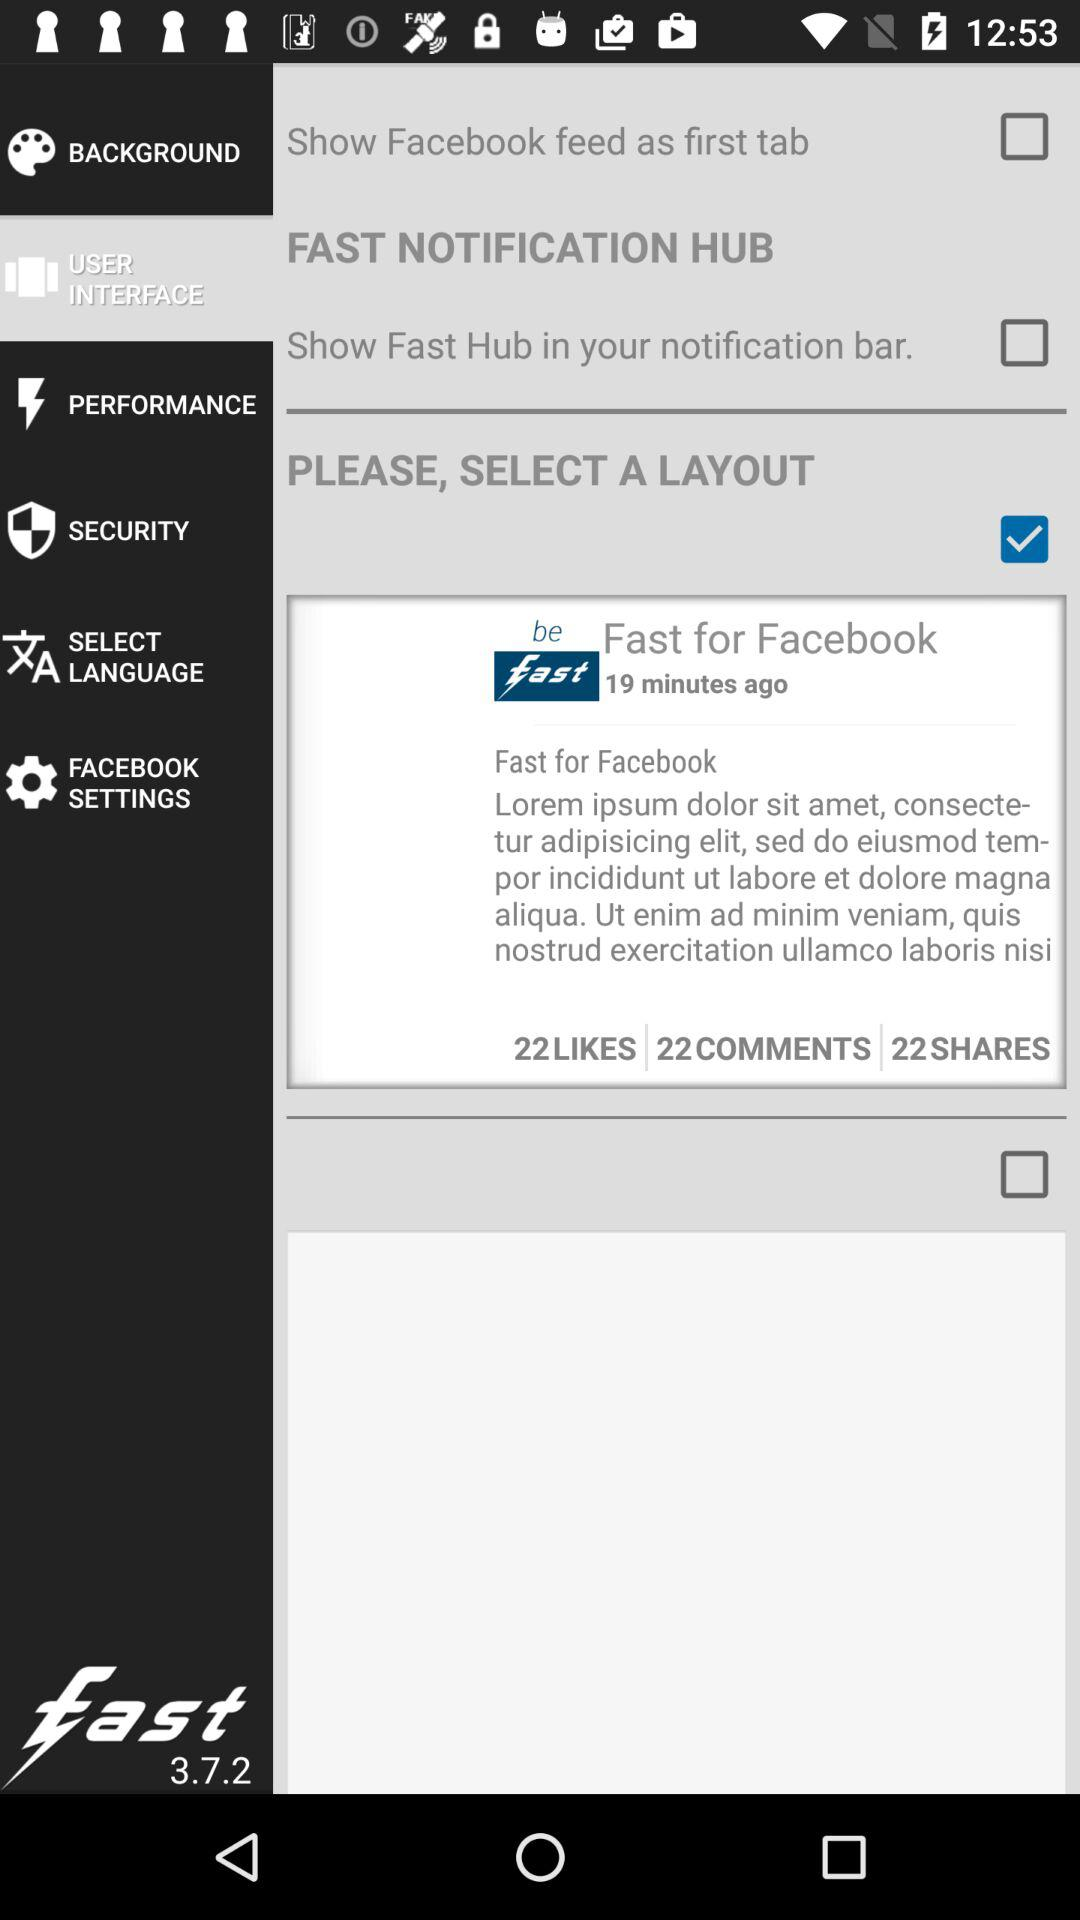Which checkbox is checked? The checked checkbox is "Fast for Facebook". 